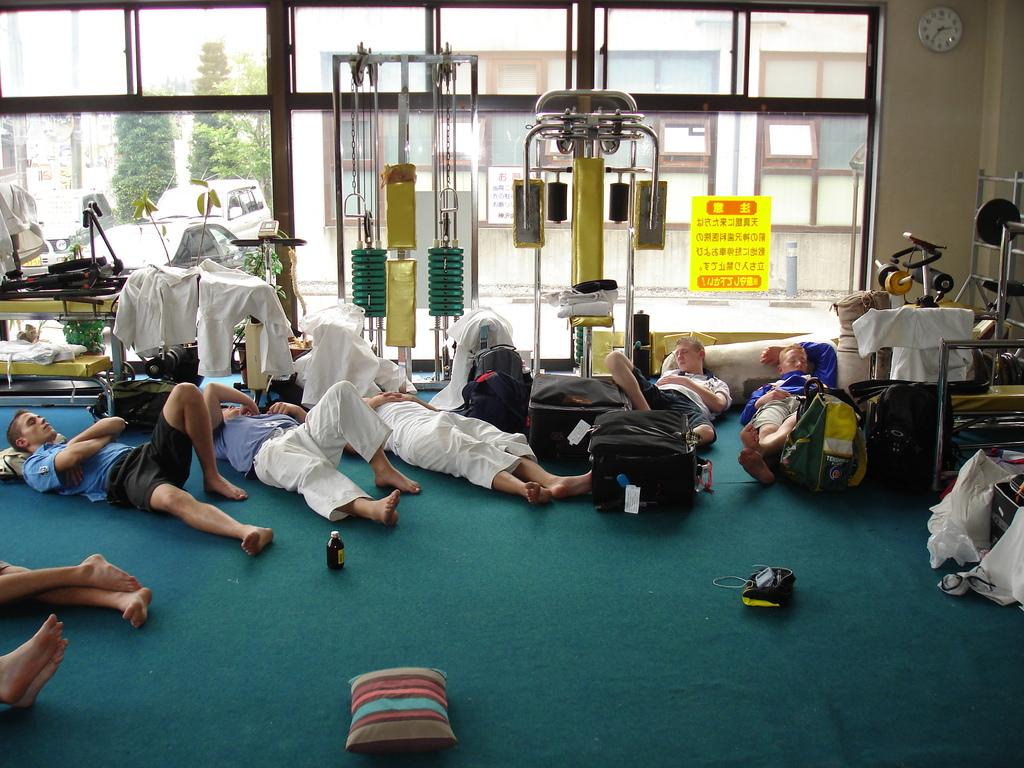What are the people in the image doing? The people in the image are sleeping. What can be seen in the sky in the image? There are clouds visible in the image. What type of equipment is present in the image? Electrical equipment is present in the image. What type of natural vegetation is in the image? There are trees in the image. What type of man-made structures are in the image? There are buildings in the image. Can you see any rabbits blowing on a pencil in the image? There are no rabbits or pencils present in the image, and therefore no such activity can be observed. 